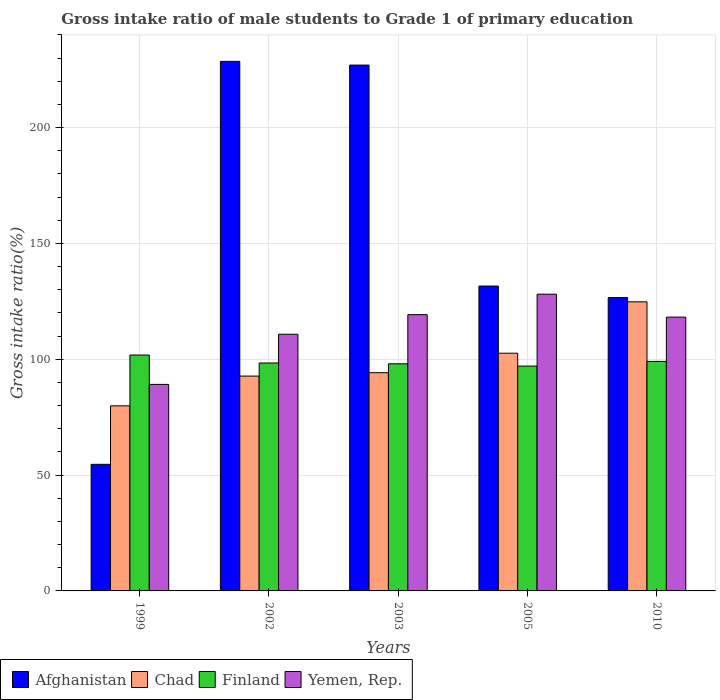How many bars are there on the 1st tick from the left?
Your response must be concise. 4. How many bars are there on the 2nd tick from the right?
Your answer should be very brief. 4. What is the label of the 5th group of bars from the left?
Offer a very short reply. 2010. What is the gross intake ratio in Finland in 2003?
Make the answer very short. 98.05. Across all years, what is the maximum gross intake ratio in Finland?
Keep it short and to the point. 101.82. Across all years, what is the minimum gross intake ratio in Chad?
Your answer should be compact. 79.9. In which year was the gross intake ratio in Chad minimum?
Your answer should be very brief. 1999. What is the total gross intake ratio in Yemen, Rep. in the graph?
Provide a succinct answer. 565.51. What is the difference between the gross intake ratio in Finland in 1999 and that in 2005?
Provide a succinct answer. 4.77. What is the difference between the gross intake ratio in Finland in 2005 and the gross intake ratio in Yemen, Rep. in 2003?
Your answer should be very brief. -22.2. What is the average gross intake ratio in Finland per year?
Your answer should be very brief. 98.88. In the year 2010, what is the difference between the gross intake ratio in Chad and gross intake ratio in Yemen, Rep.?
Your answer should be very brief. 6.6. What is the ratio of the gross intake ratio in Finland in 2005 to that in 2010?
Make the answer very short. 0.98. Is the gross intake ratio in Chad in 2002 less than that in 2003?
Your answer should be very brief. Yes. Is the difference between the gross intake ratio in Chad in 1999 and 2010 greater than the difference between the gross intake ratio in Yemen, Rep. in 1999 and 2010?
Offer a terse response. No. What is the difference between the highest and the second highest gross intake ratio in Afghanistan?
Offer a very short reply. 1.61. What is the difference between the highest and the lowest gross intake ratio in Finland?
Ensure brevity in your answer.  4.77. In how many years, is the gross intake ratio in Yemen, Rep. greater than the average gross intake ratio in Yemen, Rep. taken over all years?
Offer a terse response. 3. What does the 4th bar from the left in 2005 represents?
Provide a short and direct response. Yemen, Rep. What does the 3rd bar from the right in 2002 represents?
Keep it short and to the point. Chad. Is it the case that in every year, the sum of the gross intake ratio in Yemen, Rep. and gross intake ratio in Finland is greater than the gross intake ratio in Afghanistan?
Provide a succinct answer. No. What is the difference between two consecutive major ticks on the Y-axis?
Offer a terse response. 50. Are the values on the major ticks of Y-axis written in scientific E-notation?
Ensure brevity in your answer.  No. Does the graph contain grids?
Offer a very short reply. Yes. How many legend labels are there?
Provide a short and direct response. 4. What is the title of the graph?
Your answer should be very brief. Gross intake ratio of male students to Grade 1 of primary education. What is the label or title of the Y-axis?
Give a very brief answer. Gross intake ratio(%). What is the Gross intake ratio(%) of Afghanistan in 1999?
Make the answer very short. 54.65. What is the Gross intake ratio(%) in Chad in 1999?
Provide a succinct answer. 79.9. What is the Gross intake ratio(%) in Finland in 1999?
Your answer should be very brief. 101.82. What is the Gross intake ratio(%) in Yemen, Rep. in 1999?
Offer a terse response. 89.15. What is the Gross intake ratio(%) in Afghanistan in 2002?
Ensure brevity in your answer.  228.6. What is the Gross intake ratio(%) in Chad in 2002?
Give a very brief answer. 92.74. What is the Gross intake ratio(%) of Finland in 2002?
Your answer should be compact. 98.39. What is the Gross intake ratio(%) in Yemen, Rep. in 2002?
Offer a terse response. 110.8. What is the Gross intake ratio(%) of Afghanistan in 2003?
Provide a succinct answer. 227. What is the Gross intake ratio(%) of Chad in 2003?
Your answer should be compact. 94.19. What is the Gross intake ratio(%) in Finland in 2003?
Offer a terse response. 98.05. What is the Gross intake ratio(%) of Yemen, Rep. in 2003?
Offer a terse response. 119.26. What is the Gross intake ratio(%) of Afghanistan in 2005?
Keep it short and to the point. 131.61. What is the Gross intake ratio(%) of Chad in 2005?
Ensure brevity in your answer.  102.61. What is the Gross intake ratio(%) in Finland in 2005?
Provide a succinct answer. 97.05. What is the Gross intake ratio(%) in Yemen, Rep. in 2005?
Keep it short and to the point. 128.1. What is the Gross intake ratio(%) of Afghanistan in 2010?
Your answer should be very brief. 126.63. What is the Gross intake ratio(%) in Chad in 2010?
Your answer should be compact. 124.8. What is the Gross intake ratio(%) in Finland in 2010?
Your response must be concise. 99.08. What is the Gross intake ratio(%) of Yemen, Rep. in 2010?
Ensure brevity in your answer.  118.19. Across all years, what is the maximum Gross intake ratio(%) in Afghanistan?
Your response must be concise. 228.6. Across all years, what is the maximum Gross intake ratio(%) in Chad?
Make the answer very short. 124.8. Across all years, what is the maximum Gross intake ratio(%) in Finland?
Offer a terse response. 101.82. Across all years, what is the maximum Gross intake ratio(%) of Yemen, Rep.?
Give a very brief answer. 128.1. Across all years, what is the minimum Gross intake ratio(%) of Afghanistan?
Your answer should be very brief. 54.65. Across all years, what is the minimum Gross intake ratio(%) of Chad?
Provide a succinct answer. 79.9. Across all years, what is the minimum Gross intake ratio(%) of Finland?
Your answer should be compact. 97.05. Across all years, what is the minimum Gross intake ratio(%) in Yemen, Rep.?
Keep it short and to the point. 89.15. What is the total Gross intake ratio(%) of Afghanistan in the graph?
Offer a terse response. 768.48. What is the total Gross intake ratio(%) in Chad in the graph?
Offer a terse response. 494.25. What is the total Gross intake ratio(%) of Finland in the graph?
Offer a terse response. 494.4. What is the total Gross intake ratio(%) in Yemen, Rep. in the graph?
Make the answer very short. 565.51. What is the difference between the Gross intake ratio(%) in Afghanistan in 1999 and that in 2002?
Your response must be concise. -173.95. What is the difference between the Gross intake ratio(%) in Chad in 1999 and that in 2002?
Make the answer very short. -12.84. What is the difference between the Gross intake ratio(%) of Finland in 1999 and that in 2002?
Offer a very short reply. 3.43. What is the difference between the Gross intake ratio(%) of Yemen, Rep. in 1999 and that in 2002?
Your answer should be compact. -21.65. What is the difference between the Gross intake ratio(%) in Afghanistan in 1999 and that in 2003?
Offer a very short reply. -172.35. What is the difference between the Gross intake ratio(%) of Chad in 1999 and that in 2003?
Make the answer very short. -14.29. What is the difference between the Gross intake ratio(%) in Finland in 1999 and that in 2003?
Give a very brief answer. 3.77. What is the difference between the Gross intake ratio(%) of Yemen, Rep. in 1999 and that in 2003?
Your response must be concise. -30.1. What is the difference between the Gross intake ratio(%) of Afghanistan in 1999 and that in 2005?
Keep it short and to the point. -76.96. What is the difference between the Gross intake ratio(%) of Chad in 1999 and that in 2005?
Ensure brevity in your answer.  -22.71. What is the difference between the Gross intake ratio(%) of Finland in 1999 and that in 2005?
Ensure brevity in your answer.  4.77. What is the difference between the Gross intake ratio(%) in Yemen, Rep. in 1999 and that in 2005?
Your answer should be compact. -38.95. What is the difference between the Gross intake ratio(%) of Afghanistan in 1999 and that in 2010?
Keep it short and to the point. -71.98. What is the difference between the Gross intake ratio(%) in Chad in 1999 and that in 2010?
Your answer should be very brief. -44.9. What is the difference between the Gross intake ratio(%) of Finland in 1999 and that in 2010?
Your response must be concise. 2.74. What is the difference between the Gross intake ratio(%) of Yemen, Rep. in 1999 and that in 2010?
Ensure brevity in your answer.  -29.04. What is the difference between the Gross intake ratio(%) in Afghanistan in 2002 and that in 2003?
Give a very brief answer. 1.61. What is the difference between the Gross intake ratio(%) in Chad in 2002 and that in 2003?
Offer a terse response. -1.45. What is the difference between the Gross intake ratio(%) in Finland in 2002 and that in 2003?
Your answer should be compact. 0.35. What is the difference between the Gross intake ratio(%) of Yemen, Rep. in 2002 and that in 2003?
Ensure brevity in your answer.  -8.46. What is the difference between the Gross intake ratio(%) in Afghanistan in 2002 and that in 2005?
Provide a succinct answer. 96.99. What is the difference between the Gross intake ratio(%) in Chad in 2002 and that in 2005?
Your response must be concise. -9.87. What is the difference between the Gross intake ratio(%) in Finland in 2002 and that in 2005?
Keep it short and to the point. 1.34. What is the difference between the Gross intake ratio(%) of Yemen, Rep. in 2002 and that in 2005?
Offer a terse response. -17.3. What is the difference between the Gross intake ratio(%) of Afghanistan in 2002 and that in 2010?
Offer a terse response. 101.97. What is the difference between the Gross intake ratio(%) of Chad in 2002 and that in 2010?
Give a very brief answer. -32.06. What is the difference between the Gross intake ratio(%) of Finland in 2002 and that in 2010?
Your response must be concise. -0.68. What is the difference between the Gross intake ratio(%) of Yemen, Rep. in 2002 and that in 2010?
Provide a short and direct response. -7.39. What is the difference between the Gross intake ratio(%) in Afghanistan in 2003 and that in 2005?
Offer a very short reply. 95.39. What is the difference between the Gross intake ratio(%) of Chad in 2003 and that in 2005?
Offer a very short reply. -8.42. What is the difference between the Gross intake ratio(%) in Finland in 2003 and that in 2005?
Offer a very short reply. 1. What is the difference between the Gross intake ratio(%) of Yemen, Rep. in 2003 and that in 2005?
Provide a short and direct response. -8.84. What is the difference between the Gross intake ratio(%) in Afghanistan in 2003 and that in 2010?
Your answer should be very brief. 100.37. What is the difference between the Gross intake ratio(%) in Chad in 2003 and that in 2010?
Your response must be concise. -30.6. What is the difference between the Gross intake ratio(%) of Finland in 2003 and that in 2010?
Your answer should be very brief. -1.03. What is the difference between the Gross intake ratio(%) of Yemen, Rep. in 2003 and that in 2010?
Give a very brief answer. 1.06. What is the difference between the Gross intake ratio(%) in Afghanistan in 2005 and that in 2010?
Provide a succinct answer. 4.98. What is the difference between the Gross intake ratio(%) in Chad in 2005 and that in 2010?
Give a very brief answer. -22.19. What is the difference between the Gross intake ratio(%) in Finland in 2005 and that in 2010?
Provide a short and direct response. -2.02. What is the difference between the Gross intake ratio(%) in Yemen, Rep. in 2005 and that in 2010?
Ensure brevity in your answer.  9.91. What is the difference between the Gross intake ratio(%) of Afghanistan in 1999 and the Gross intake ratio(%) of Chad in 2002?
Offer a very short reply. -38.09. What is the difference between the Gross intake ratio(%) in Afghanistan in 1999 and the Gross intake ratio(%) in Finland in 2002?
Your answer should be compact. -43.75. What is the difference between the Gross intake ratio(%) in Afghanistan in 1999 and the Gross intake ratio(%) in Yemen, Rep. in 2002?
Make the answer very short. -56.15. What is the difference between the Gross intake ratio(%) in Chad in 1999 and the Gross intake ratio(%) in Finland in 2002?
Offer a terse response. -18.49. What is the difference between the Gross intake ratio(%) in Chad in 1999 and the Gross intake ratio(%) in Yemen, Rep. in 2002?
Make the answer very short. -30.9. What is the difference between the Gross intake ratio(%) in Finland in 1999 and the Gross intake ratio(%) in Yemen, Rep. in 2002?
Your answer should be compact. -8.98. What is the difference between the Gross intake ratio(%) in Afghanistan in 1999 and the Gross intake ratio(%) in Chad in 2003?
Your answer should be very brief. -39.55. What is the difference between the Gross intake ratio(%) in Afghanistan in 1999 and the Gross intake ratio(%) in Finland in 2003?
Ensure brevity in your answer.  -43.4. What is the difference between the Gross intake ratio(%) of Afghanistan in 1999 and the Gross intake ratio(%) of Yemen, Rep. in 2003?
Make the answer very short. -64.61. What is the difference between the Gross intake ratio(%) in Chad in 1999 and the Gross intake ratio(%) in Finland in 2003?
Give a very brief answer. -18.15. What is the difference between the Gross intake ratio(%) of Chad in 1999 and the Gross intake ratio(%) of Yemen, Rep. in 2003?
Your answer should be compact. -39.36. What is the difference between the Gross intake ratio(%) in Finland in 1999 and the Gross intake ratio(%) in Yemen, Rep. in 2003?
Ensure brevity in your answer.  -17.43. What is the difference between the Gross intake ratio(%) in Afghanistan in 1999 and the Gross intake ratio(%) in Chad in 2005?
Your answer should be compact. -47.96. What is the difference between the Gross intake ratio(%) of Afghanistan in 1999 and the Gross intake ratio(%) of Finland in 2005?
Give a very brief answer. -42.4. What is the difference between the Gross intake ratio(%) in Afghanistan in 1999 and the Gross intake ratio(%) in Yemen, Rep. in 2005?
Provide a short and direct response. -73.45. What is the difference between the Gross intake ratio(%) in Chad in 1999 and the Gross intake ratio(%) in Finland in 2005?
Your answer should be compact. -17.15. What is the difference between the Gross intake ratio(%) of Chad in 1999 and the Gross intake ratio(%) of Yemen, Rep. in 2005?
Your answer should be compact. -48.2. What is the difference between the Gross intake ratio(%) in Finland in 1999 and the Gross intake ratio(%) in Yemen, Rep. in 2005?
Provide a short and direct response. -26.28. What is the difference between the Gross intake ratio(%) of Afghanistan in 1999 and the Gross intake ratio(%) of Chad in 2010?
Your answer should be very brief. -70.15. What is the difference between the Gross intake ratio(%) of Afghanistan in 1999 and the Gross intake ratio(%) of Finland in 2010?
Make the answer very short. -44.43. What is the difference between the Gross intake ratio(%) in Afghanistan in 1999 and the Gross intake ratio(%) in Yemen, Rep. in 2010?
Your answer should be very brief. -63.55. What is the difference between the Gross intake ratio(%) of Chad in 1999 and the Gross intake ratio(%) of Finland in 2010?
Your answer should be very brief. -19.18. What is the difference between the Gross intake ratio(%) of Chad in 1999 and the Gross intake ratio(%) of Yemen, Rep. in 2010?
Offer a terse response. -38.29. What is the difference between the Gross intake ratio(%) of Finland in 1999 and the Gross intake ratio(%) of Yemen, Rep. in 2010?
Make the answer very short. -16.37. What is the difference between the Gross intake ratio(%) of Afghanistan in 2002 and the Gross intake ratio(%) of Chad in 2003?
Offer a terse response. 134.41. What is the difference between the Gross intake ratio(%) in Afghanistan in 2002 and the Gross intake ratio(%) in Finland in 2003?
Provide a succinct answer. 130.55. What is the difference between the Gross intake ratio(%) in Afghanistan in 2002 and the Gross intake ratio(%) in Yemen, Rep. in 2003?
Offer a terse response. 109.34. What is the difference between the Gross intake ratio(%) of Chad in 2002 and the Gross intake ratio(%) of Finland in 2003?
Offer a terse response. -5.31. What is the difference between the Gross intake ratio(%) in Chad in 2002 and the Gross intake ratio(%) in Yemen, Rep. in 2003?
Offer a very short reply. -26.52. What is the difference between the Gross intake ratio(%) of Finland in 2002 and the Gross intake ratio(%) of Yemen, Rep. in 2003?
Make the answer very short. -20.86. What is the difference between the Gross intake ratio(%) in Afghanistan in 2002 and the Gross intake ratio(%) in Chad in 2005?
Provide a short and direct response. 125.99. What is the difference between the Gross intake ratio(%) in Afghanistan in 2002 and the Gross intake ratio(%) in Finland in 2005?
Make the answer very short. 131.55. What is the difference between the Gross intake ratio(%) in Afghanistan in 2002 and the Gross intake ratio(%) in Yemen, Rep. in 2005?
Keep it short and to the point. 100.5. What is the difference between the Gross intake ratio(%) of Chad in 2002 and the Gross intake ratio(%) of Finland in 2005?
Provide a short and direct response. -4.31. What is the difference between the Gross intake ratio(%) of Chad in 2002 and the Gross intake ratio(%) of Yemen, Rep. in 2005?
Your response must be concise. -35.36. What is the difference between the Gross intake ratio(%) of Finland in 2002 and the Gross intake ratio(%) of Yemen, Rep. in 2005?
Provide a short and direct response. -29.7. What is the difference between the Gross intake ratio(%) in Afghanistan in 2002 and the Gross intake ratio(%) in Chad in 2010?
Provide a short and direct response. 103.8. What is the difference between the Gross intake ratio(%) of Afghanistan in 2002 and the Gross intake ratio(%) of Finland in 2010?
Keep it short and to the point. 129.52. What is the difference between the Gross intake ratio(%) of Afghanistan in 2002 and the Gross intake ratio(%) of Yemen, Rep. in 2010?
Provide a short and direct response. 110.41. What is the difference between the Gross intake ratio(%) of Chad in 2002 and the Gross intake ratio(%) of Finland in 2010?
Offer a terse response. -6.34. What is the difference between the Gross intake ratio(%) of Chad in 2002 and the Gross intake ratio(%) of Yemen, Rep. in 2010?
Give a very brief answer. -25.45. What is the difference between the Gross intake ratio(%) of Finland in 2002 and the Gross intake ratio(%) of Yemen, Rep. in 2010?
Ensure brevity in your answer.  -19.8. What is the difference between the Gross intake ratio(%) of Afghanistan in 2003 and the Gross intake ratio(%) of Chad in 2005?
Give a very brief answer. 124.38. What is the difference between the Gross intake ratio(%) in Afghanistan in 2003 and the Gross intake ratio(%) in Finland in 2005?
Give a very brief answer. 129.94. What is the difference between the Gross intake ratio(%) of Afghanistan in 2003 and the Gross intake ratio(%) of Yemen, Rep. in 2005?
Your answer should be compact. 98.9. What is the difference between the Gross intake ratio(%) in Chad in 2003 and the Gross intake ratio(%) in Finland in 2005?
Your response must be concise. -2.86. What is the difference between the Gross intake ratio(%) of Chad in 2003 and the Gross intake ratio(%) of Yemen, Rep. in 2005?
Offer a terse response. -33.91. What is the difference between the Gross intake ratio(%) in Finland in 2003 and the Gross intake ratio(%) in Yemen, Rep. in 2005?
Provide a short and direct response. -30.05. What is the difference between the Gross intake ratio(%) in Afghanistan in 2003 and the Gross intake ratio(%) in Chad in 2010?
Provide a short and direct response. 102.2. What is the difference between the Gross intake ratio(%) in Afghanistan in 2003 and the Gross intake ratio(%) in Finland in 2010?
Make the answer very short. 127.92. What is the difference between the Gross intake ratio(%) in Afghanistan in 2003 and the Gross intake ratio(%) in Yemen, Rep. in 2010?
Give a very brief answer. 108.8. What is the difference between the Gross intake ratio(%) of Chad in 2003 and the Gross intake ratio(%) of Finland in 2010?
Provide a short and direct response. -4.88. What is the difference between the Gross intake ratio(%) in Chad in 2003 and the Gross intake ratio(%) in Yemen, Rep. in 2010?
Provide a short and direct response. -24. What is the difference between the Gross intake ratio(%) of Finland in 2003 and the Gross intake ratio(%) of Yemen, Rep. in 2010?
Your answer should be compact. -20.15. What is the difference between the Gross intake ratio(%) of Afghanistan in 2005 and the Gross intake ratio(%) of Chad in 2010?
Keep it short and to the point. 6.81. What is the difference between the Gross intake ratio(%) of Afghanistan in 2005 and the Gross intake ratio(%) of Finland in 2010?
Provide a short and direct response. 32.53. What is the difference between the Gross intake ratio(%) in Afghanistan in 2005 and the Gross intake ratio(%) in Yemen, Rep. in 2010?
Your answer should be compact. 13.41. What is the difference between the Gross intake ratio(%) of Chad in 2005 and the Gross intake ratio(%) of Finland in 2010?
Provide a succinct answer. 3.53. What is the difference between the Gross intake ratio(%) of Chad in 2005 and the Gross intake ratio(%) of Yemen, Rep. in 2010?
Your answer should be very brief. -15.58. What is the difference between the Gross intake ratio(%) of Finland in 2005 and the Gross intake ratio(%) of Yemen, Rep. in 2010?
Your answer should be compact. -21.14. What is the average Gross intake ratio(%) in Afghanistan per year?
Offer a terse response. 153.7. What is the average Gross intake ratio(%) of Chad per year?
Ensure brevity in your answer.  98.85. What is the average Gross intake ratio(%) in Finland per year?
Offer a very short reply. 98.88. What is the average Gross intake ratio(%) of Yemen, Rep. per year?
Your answer should be compact. 113.1. In the year 1999, what is the difference between the Gross intake ratio(%) of Afghanistan and Gross intake ratio(%) of Chad?
Keep it short and to the point. -25.25. In the year 1999, what is the difference between the Gross intake ratio(%) in Afghanistan and Gross intake ratio(%) in Finland?
Make the answer very short. -47.17. In the year 1999, what is the difference between the Gross intake ratio(%) of Afghanistan and Gross intake ratio(%) of Yemen, Rep.?
Keep it short and to the point. -34.5. In the year 1999, what is the difference between the Gross intake ratio(%) in Chad and Gross intake ratio(%) in Finland?
Give a very brief answer. -21.92. In the year 1999, what is the difference between the Gross intake ratio(%) of Chad and Gross intake ratio(%) of Yemen, Rep.?
Offer a terse response. -9.25. In the year 1999, what is the difference between the Gross intake ratio(%) in Finland and Gross intake ratio(%) in Yemen, Rep.?
Make the answer very short. 12.67. In the year 2002, what is the difference between the Gross intake ratio(%) of Afghanistan and Gross intake ratio(%) of Chad?
Keep it short and to the point. 135.86. In the year 2002, what is the difference between the Gross intake ratio(%) of Afghanistan and Gross intake ratio(%) of Finland?
Your answer should be compact. 130.21. In the year 2002, what is the difference between the Gross intake ratio(%) of Afghanistan and Gross intake ratio(%) of Yemen, Rep.?
Provide a short and direct response. 117.8. In the year 2002, what is the difference between the Gross intake ratio(%) of Chad and Gross intake ratio(%) of Finland?
Your response must be concise. -5.65. In the year 2002, what is the difference between the Gross intake ratio(%) in Chad and Gross intake ratio(%) in Yemen, Rep.?
Your answer should be very brief. -18.06. In the year 2002, what is the difference between the Gross intake ratio(%) of Finland and Gross intake ratio(%) of Yemen, Rep.?
Offer a very short reply. -12.41. In the year 2003, what is the difference between the Gross intake ratio(%) of Afghanistan and Gross intake ratio(%) of Chad?
Provide a succinct answer. 132.8. In the year 2003, what is the difference between the Gross intake ratio(%) of Afghanistan and Gross intake ratio(%) of Finland?
Your answer should be compact. 128.95. In the year 2003, what is the difference between the Gross intake ratio(%) in Afghanistan and Gross intake ratio(%) in Yemen, Rep.?
Provide a short and direct response. 107.74. In the year 2003, what is the difference between the Gross intake ratio(%) in Chad and Gross intake ratio(%) in Finland?
Give a very brief answer. -3.85. In the year 2003, what is the difference between the Gross intake ratio(%) of Chad and Gross intake ratio(%) of Yemen, Rep.?
Provide a succinct answer. -25.06. In the year 2003, what is the difference between the Gross intake ratio(%) in Finland and Gross intake ratio(%) in Yemen, Rep.?
Provide a succinct answer. -21.21. In the year 2005, what is the difference between the Gross intake ratio(%) in Afghanistan and Gross intake ratio(%) in Chad?
Ensure brevity in your answer.  28.99. In the year 2005, what is the difference between the Gross intake ratio(%) of Afghanistan and Gross intake ratio(%) of Finland?
Offer a very short reply. 34.55. In the year 2005, what is the difference between the Gross intake ratio(%) of Afghanistan and Gross intake ratio(%) of Yemen, Rep.?
Offer a terse response. 3.51. In the year 2005, what is the difference between the Gross intake ratio(%) in Chad and Gross intake ratio(%) in Finland?
Give a very brief answer. 5.56. In the year 2005, what is the difference between the Gross intake ratio(%) in Chad and Gross intake ratio(%) in Yemen, Rep.?
Offer a terse response. -25.49. In the year 2005, what is the difference between the Gross intake ratio(%) of Finland and Gross intake ratio(%) of Yemen, Rep.?
Make the answer very short. -31.05. In the year 2010, what is the difference between the Gross intake ratio(%) of Afghanistan and Gross intake ratio(%) of Chad?
Give a very brief answer. 1.83. In the year 2010, what is the difference between the Gross intake ratio(%) in Afghanistan and Gross intake ratio(%) in Finland?
Make the answer very short. 27.55. In the year 2010, what is the difference between the Gross intake ratio(%) of Afghanistan and Gross intake ratio(%) of Yemen, Rep.?
Provide a short and direct response. 8.44. In the year 2010, what is the difference between the Gross intake ratio(%) of Chad and Gross intake ratio(%) of Finland?
Offer a terse response. 25.72. In the year 2010, what is the difference between the Gross intake ratio(%) of Chad and Gross intake ratio(%) of Yemen, Rep.?
Keep it short and to the point. 6.6. In the year 2010, what is the difference between the Gross intake ratio(%) of Finland and Gross intake ratio(%) of Yemen, Rep.?
Ensure brevity in your answer.  -19.12. What is the ratio of the Gross intake ratio(%) of Afghanistan in 1999 to that in 2002?
Keep it short and to the point. 0.24. What is the ratio of the Gross intake ratio(%) of Chad in 1999 to that in 2002?
Provide a succinct answer. 0.86. What is the ratio of the Gross intake ratio(%) in Finland in 1999 to that in 2002?
Give a very brief answer. 1.03. What is the ratio of the Gross intake ratio(%) in Yemen, Rep. in 1999 to that in 2002?
Keep it short and to the point. 0.8. What is the ratio of the Gross intake ratio(%) of Afghanistan in 1999 to that in 2003?
Provide a short and direct response. 0.24. What is the ratio of the Gross intake ratio(%) in Chad in 1999 to that in 2003?
Your answer should be compact. 0.85. What is the ratio of the Gross intake ratio(%) of Finland in 1999 to that in 2003?
Your response must be concise. 1.04. What is the ratio of the Gross intake ratio(%) in Yemen, Rep. in 1999 to that in 2003?
Your answer should be compact. 0.75. What is the ratio of the Gross intake ratio(%) in Afghanistan in 1999 to that in 2005?
Make the answer very short. 0.42. What is the ratio of the Gross intake ratio(%) in Chad in 1999 to that in 2005?
Offer a terse response. 0.78. What is the ratio of the Gross intake ratio(%) of Finland in 1999 to that in 2005?
Provide a short and direct response. 1.05. What is the ratio of the Gross intake ratio(%) in Yemen, Rep. in 1999 to that in 2005?
Provide a short and direct response. 0.7. What is the ratio of the Gross intake ratio(%) of Afghanistan in 1999 to that in 2010?
Your response must be concise. 0.43. What is the ratio of the Gross intake ratio(%) in Chad in 1999 to that in 2010?
Make the answer very short. 0.64. What is the ratio of the Gross intake ratio(%) in Finland in 1999 to that in 2010?
Your response must be concise. 1.03. What is the ratio of the Gross intake ratio(%) in Yemen, Rep. in 1999 to that in 2010?
Your response must be concise. 0.75. What is the ratio of the Gross intake ratio(%) in Afghanistan in 2002 to that in 2003?
Give a very brief answer. 1.01. What is the ratio of the Gross intake ratio(%) in Chad in 2002 to that in 2003?
Your response must be concise. 0.98. What is the ratio of the Gross intake ratio(%) in Finland in 2002 to that in 2003?
Ensure brevity in your answer.  1. What is the ratio of the Gross intake ratio(%) in Yemen, Rep. in 2002 to that in 2003?
Offer a terse response. 0.93. What is the ratio of the Gross intake ratio(%) in Afghanistan in 2002 to that in 2005?
Give a very brief answer. 1.74. What is the ratio of the Gross intake ratio(%) in Chad in 2002 to that in 2005?
Ensure brevity in your answer.  0.9. What is the ratio of the Gross intake ratio(%) in Finland in 2002 to that in 2005?
Make the answer very short. 1.01. What is the ratio of the Gross intake ratio(%) in Yemen, Rep. in 2002 to that in 2005?
Give a very brief answer. 0.86. What is the ratio of the Gross intake ratio(%) of Afghanistan in 2002 to that in 2010?
Keep it short and to the point. 1.81. What is the ratio of the Gross intake ratio(%) of Chad in 2002 to that in 2010?
Offer a very short reply. 0.74. What is the ratio of the Gross intake ratio(%) in Afghanistan in 2003 to that in 2005?
Give a very brief answer. 1.72. What is the ratio of the Gross intake ratio(%) in Chad in 2003 to that in 2005?
Your answer should be compact. 0.92. What is the ratio of the Gross intake ratio(%) in Finland in 2003 to that in 2005?
Your answer should be compact. 1.01. What is the ratio of the Gross intake ratio(%) in Yemen, Rep. in 2003 to that in 2005?
Provide a short and direct response. 0.93. What is the ratio of the Gross intake ratio(%) of Afghanistan in 2003 to that in 2010?
Provide a succinct answer. 1.79. What is the ratio of the Gross intake ratio(%) in Chad in 2003 to that in 2010?
Provide a short and direct response. 0.75. What is the ratio of the Gross intake ratio(%) in Yemen, Rep. in 2003 to that in 2010?
Make the answer very short. 1.01. What is the ratio of the Gross intake ratio(%) of Afghanistan in 2005 to that in 2010?
Ensure brevity in your answer.  1.04. What is the ratio of the Gross intake ratio(%) of Chad in 2005 to that in 2010?
Keep it short and to the point. 0.82. What is the ratio of the Gross intake ratio(%) in Finland in 2005 to that in 2010?
Give a very brief answer. 0.98. What is the ratio of the Gross intake ratio(%) in Yemen, Rep. in 2005 to that in 2010?
Provide a short and direct response. 1.08. What is the difference between the highest and the second highest Gross intake ratio(%) in Afghanistan?
Your response must be concise. 1.61. What is the difference between the highest and the second highest Gross intake ratio(%) of Chad?
Give a very brief answer. 22.19. What is the difference between the highest and the second highest Gross intake ratio(%) of Finland?
Your answer should be very brief. 2.74. What is the difference between the highest and the second highest Gross intake ratio(%) in Yemen, Rep.?
Provide a short and direct response. 8.84. What is the difference between the highest and the lowest Gross intake ratio(%) in Afghanistan?
Give a very brief answer. 173.95. What is the difference between the highest and the lowest Gross intake ratio(%) of Chad?
Your answer should be very brief. 44.9. What is the difference between the highest and the lowest Gross intake ratio(%) in Finland?
Provide a short and direct response. 4.77. What is the difference between the highest and the lowest Gross intake ratio(%) in Yemen, Rep.?
Offer a very short reply. 38.95. 